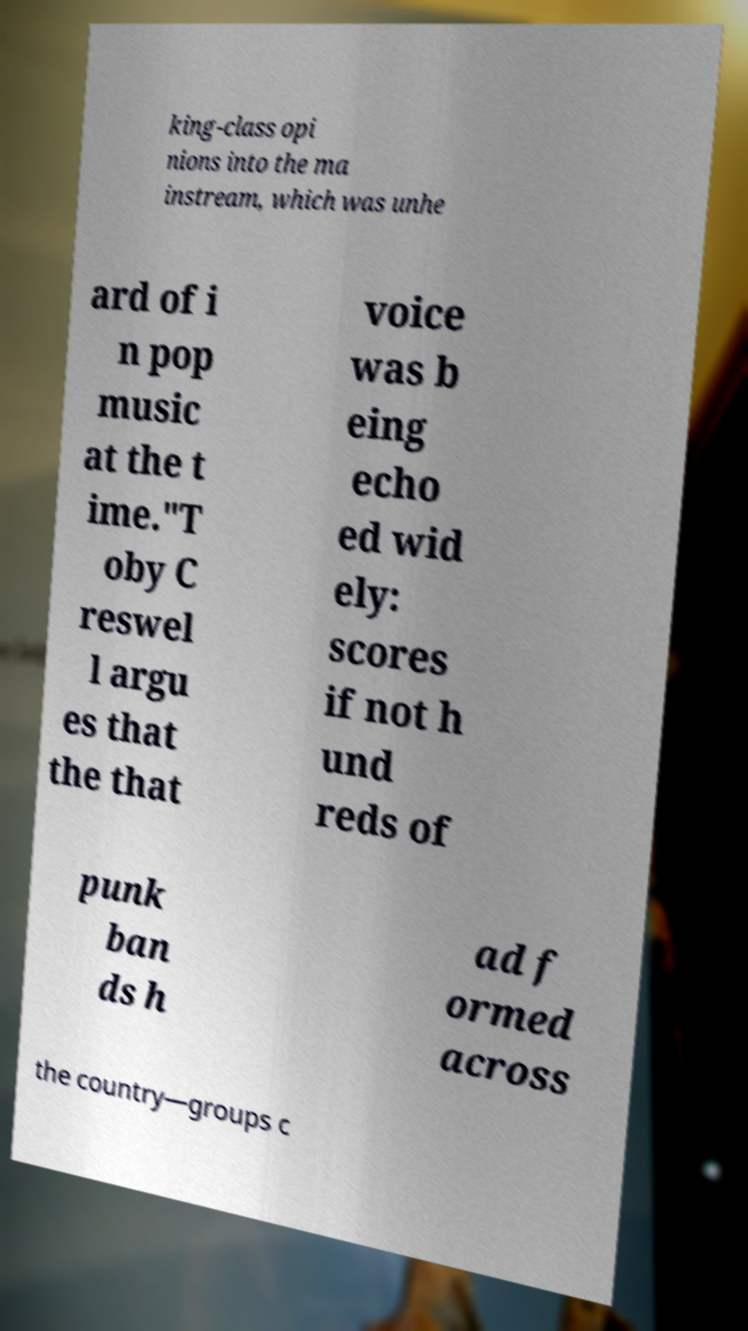Please read and relay the text visible in this image. What does it say? king-class opi nions into the ma instream, which was unhe ard of i n pop music at the t ime."T oby C reswel l argu es that the that voice was b eing echo ed wid ely: scores if not h und reds of punk ban ds h ad f ormed across the country—groups c 